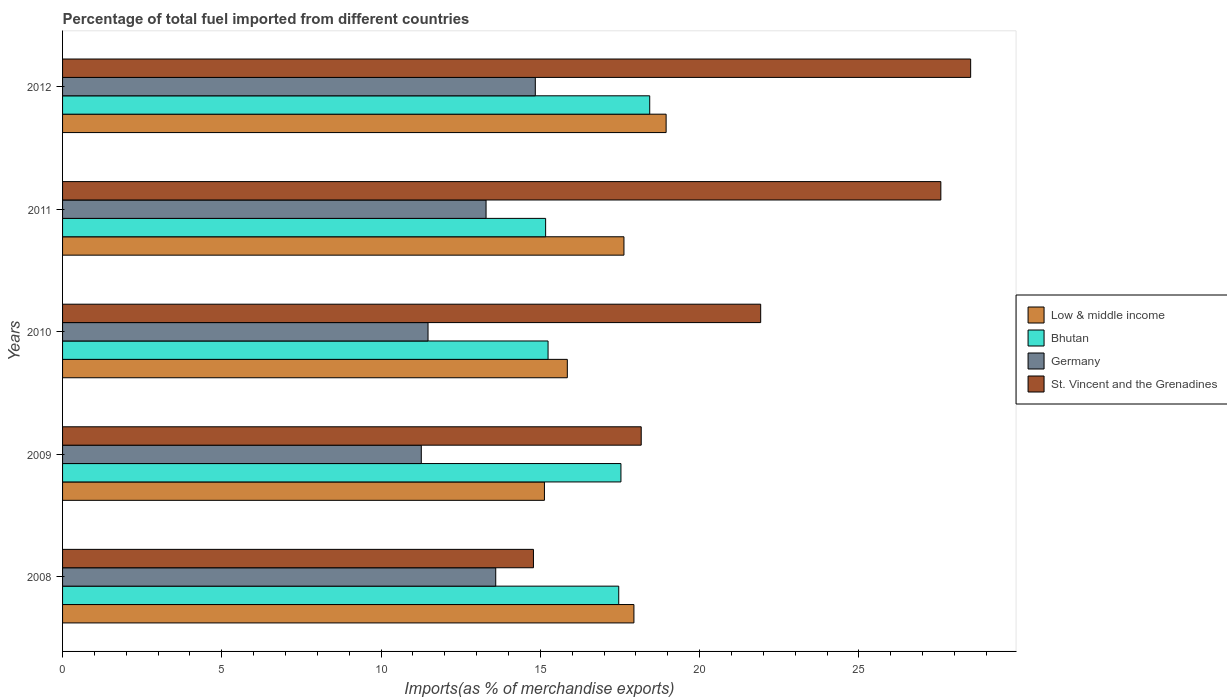How many different coloured bars are there?
Keep it short and to the point. 4. How many groups of bars are there?
Provide a short and direct response. 5. Are the number of bars per tick equal to the number of legend labels?
Your answer should be compact. Yes. What is the label of the 3rd group of bars from the top?
Ensure brevity in your answer.  2010. In how many cases, is the number of bars for a given year not equal to the number of legend labels?
Make the answer very short. 0. What is the percentage of imports to different countries in Bhutan in 2010?
Give a very brief answer. 15.24. Across all years, what is the maximum percentage of imports to different countries in Germany?
Provide a short and direct response. 14.84. Across all years, what is the minimum percentage of imports to different countries in St. Vincent and the Grenadines?
Ensure brevity in your answer.  14.78. In which year was the percentage of imports to different countries in Germany minimum?
Offer a very short reply. 2009. What is the total percentage of imports to different countries in St. Vincent and the Grenadines in the graph?
Offer a terse response. 110.95. What is the difference between the percentage of imports to different countries in Low & middle income in 2008 and that in 2012?
Your answer should be compact. -1.01. What is the difference between the percentage of imports to different countries in Bhutan in 2008 and the percentage of imports to different countries in Germany in 2012?
Keep it short and to the point. 2.62. What is the average percentage of imports to different countries in Germany per year?
Your answer should be compact. 12.89. In the year 2009, what is the difference between the percentage of imports to different countries in Germany and percentage of imports to different countries in St. Vincent and the Grenadines?
Keep it short and to the point. -6.9. In how many years, is the percentage of imports to different countries in St. Vincent and the Grenadines greater than 28 %?
Give a very brief answer. 1. What is the ratio of the percentage of imports to different countries in Low & middle income in 2009 to that in 2011?
Make the answer very short. 0.86. What is the difference between the highest and the second highest percentage of imports to different countries in Germany?
Offer a very short reply. 1.24. What is the difference between the highest and the lowest percentage of imports to different countries in Germany?
Give a very brief answer. 3.58. How many bars are there?
Your response must be concise. 20. Are all the bars in the graph horizontal?
Ensure brevity in your answer.  Yes. How many years are there in the graph?
Your answer should be very brief. 5. How are the legend labels stacked?
Ensure brevity in your answer.  Vertical. What is the title of the graph?
Keep it short and to the point. Percentage of total fuel imported from different countries. What is the label or title of the X-axis?
Provide a short and direct response. Imports(as % of merchandise exports). What is the Imports(as % of merchandise exports) of Low & middle income in 2008?
Keep it short and to the point. 17.94. What is the Imports(as % of merchandise exports) of Bhutan in 2008?
Your answer should be compact. 17.46. What is the Imports(as % of merchandise exports) in Germany in 2008?
Make the answer very short. 13.6. What is the Imports(as % of merchandise exports) of St. Vincent and the Grenadines in 2008?
Offer a very short reply. 14.78. What is the Imports(as % of merchandise exports) in Low & middle income in 2009?
Offer a very short reply. 15.13. What is the Imports(as % of merchandise exports) of Bhutan in 2009?
Your answer should be very brief. 17.53. What is the Imports(as % of merchandise exports) in Germany in 2009?
Make the answer very short. 11.26. What is the Imports(as % of merchandise exports) of St. Vincent and the Grenadines in 2009?
Give a very brief answer. 18.17. What is the Imports(as % of merchandise exports) of Low & middle income in 2010?
Make the answer very short. 15.85. What is the Imports(as % of merchandise exports) of Bhutan in 2010?
Make the answer very short. 15.24. What is the Imports(as % of merchandise exports) in Germany in 2010?
Your answer should be very brief. 11.47. What is the Imports(as % of merchandise exports) in St. Vincent and the Grenadines in 2010?
Provide a short and direct response. 21.92. What is the Imports(as % of merchandise exports) of Low & middle income in 2011?
Give a very brief answer. 17.62. What is the Imports(as % of merchandise exports) in Bhutan in 2011?
Provide a succinct answer. 15.16. What is the Imports(as % of merchandise exports) in Germany in 2011?
Make the answer very short. 13.3. What is the Imports(as % of merchandise exports) of St. Vincent and the Grenadines in 2011?
Make the answer very short. 27.57. What is the Imports(as % of merchandise exports) of Low & middle income in 2012?
Provide a short and direct response. 18.95. What is the Imports(as % of merchandise exports) of Bhutan in 2012?
Make the answer very short. 18.43. What is the Imports(as % of merchandise exports) of Germany in 2012?
Provide a succinct answer. 14.84. What is the Imports(as % of merchandise exports) of St. Vincent and the Grenadines in 2012?
Ensure brevity in your answer.  28.51. Across all years, what is the maximum Imports(as % of merchandise exports) in Low & middle income?
Make the answer very short. 18.95. Across all years, what is the maximum Imports(as % of merchandise exports) of Bhutan?
Your answer should be compact. 18.43. Across all years, what is the maximum Imports(as % of merchandise exports) of Germany?
Offer a terse response. 14.84. Across all years, what is the maximum Imports(as % of merchandise exports) of St. Vincent and the Grenadines?
Provide a succinct answer. 28.51. Across all years, what is the minimum Imports(as % of merchandise exports) of Low & middle income?
Make the answer very short. 15.13. Across all years, what is the minimum Imports(as % of merchandise exports) in Bhutan?
Give a very brief answer. 15.16. Across all years, what is the minimum Imports(as % of merchandise exports) of Germany?
Give a very brief answer. 11.26. Across all years, what is the minimum Imports(as % of merchandise exports) in St. Vincent and the Grenadines?
Provide a short and direct response. 14.78. What is the total Imports(as % of merchandise exports) of Low & middle income in the graph?
Your response must be concise. 85.48. What is the total Imports(as % of merchandise exports) in Bhutan in the graph?
Your answer should be compact. 83.83. What is the total Imports(as % of merchandise exports) of Germany in the graph?
Provide a succinct answer. 64.47. What is the total Imports(as % of merchandise exports) in St. Vincent and the Grenadines in the graph?
Your answer should be very brief. 110.95. What is the difference between the Imports(as % of merchandise exports) of Low & middle income in 2008 and that in 2009?
Keep it short and to the point. 2.81. What is the difference between the Imports(as % of merchandise exports) in Bhutan in 2008 and that in 2009?
Offer a very short reply. -0.07. What is the difference between the Imports(as % of merchandise exports) of Germany in 2008 and that in 2009?
Make the answer very short. 2.34. What is the difference between the Imports(as % of merchandise exports) of St. Vincent and the Grenadines in 2008 and that in 2009?
Keep it short and to the point. -3.38. What is the difference between the Imports(as % of merchandise exports) of Low & middle income in 2008 and that in 2010?
Your answer should be very brief. 2.09. What is the difference between the Imports(as % of merchandise exports) of Bhutan in 2008 and that in 2010?
Keep it short and to the point. 2.22. What is the difference between the Imports(as % of merchandise exports) in Germany in 2008 and that in 2010?
Your response must be concise. 2.13. What is the difference between the Imports(as % of merchandise exports) in St. Vincent and the Grenadines in 2008 and that in 2010?
Keep it short and to the point. -7.13. What is the difference between the Imports(as % of merchandise exports) of Low & middle income in 2008 and that in 2011?
Your answer should be compact. 0.31. What is the difference between the Imports(as % of merchandise exports) of Bhutan in 2008 and that in 2011?
Give a very brief answer. 2.3. What is the difference between the Imports(as % of merchandise exports) of Germany in 2008 and that in 2011?
Provide a succinct answer. 0.3. What is the difference between the Imports(as % of merchandise exports) of St. Vincent and the Grenadines in 2008 and that in 2011?
Ensure brevity in your answer.  -12.79. What is the difference between the Imports(as % of merchandise exports) of Low & middle income in 2008 and that in 2012?
Make the answer very short. -1.01. What is the difference between the Imports(as % of merchandise exports) in Bhutan in 2008 and that in 2012?
Your response must be concise. -0.97. What is the difference between the Imports(as % of merchandise exports) of Germany in 2008 and that in 2012?
Ensure brevity in your answer.  -1.24. What is the difference between the Imports(as % of merchandise exports) in St. Vincent and the Grenadines in 2008 and that in 2012?
Provide a short and direct response. -13.73. What is the difference between the Imports(as % of merchandise exports) of Low & middle income in 2009 and that in 2010?
Give a very brief answer. -0.72. What is the difference between the Imports(as % of merchandise exports) of Bhutan in 2009 and that in 2010?
Your answer should be very brief. 2.29. What is the difference between the Imports(as % of merchandise exports) in Germany in 2009 and that in 2010?
Provide a short and direct response. -0.21. What is the difference between the Imports(as % of merchandise exports) in St. Vincent and the Grenadines in 2009 and that in 2010?
Offer a terse response. -3.75. What is the difference between the Imports(as % of merchandise exports) of Low & middle income in 2009 and that in 2011?
Your answer should be compact. -2.5. What is the difference between the Imports(as % of merchandise exports) of Bhutan in 2009 and that in 2011?
Make the answer very short. 2.36. What is the difference between the Imports(as % of merchandise exports) in Germany in 2009 and that in 2011?
Keep it short and to the point. -2.03. What is the difference between the Imports(as % of merchandise exports) in St. Vincent and the Grenadines in 2009 and that in 2011?
Keep it short and to the point. -9.41. What is the difference between the Imports(as % of merchandise exports) of Low & middle income in 2009 and that in 2012?
Provide a succinct answer. -3.82. What is the difference between the Imports(as % of merchandise exports) of Bhutan in 2009 and that in 2012?
Ensure brevity in your answer.  -0.9. What is the difference between the Imports(as % of merchandise exports) of Germany in 2009 and that in 2012?
Ensure brevity in your answer.  -3.58. What is the difference between the Imports(as % of merchandise exports) of St. Vincent and the Grenadines in 2009 and that in 2012?
Keep it short and to the point. -10.34. What is the difference between the Imports(as % of merchandise exports) of Low & middle income in 2010 and that in 2011?
Offer a terse response. -1.78. What is the difference between the Imports(as % of merchandise exports) in Bhutan in 2010 and that in 2011?
Ensure brevity in your answer.  0.08. What is the difference between the Imports(as % of merchandise exports) of Germany in 2010 and that in 2011?
Your response must be concise. -1.82. What is the difference between the Imports(as % of merchandise exports) of St. Vincent and the Grenadines in 2010 and that in 2011?
Give a very brief answer. -5.66. What is the difference between the Imports(as % of merchandise exports) in Low & middle income in 2010 and that in 2012?
Your answer should be very brief. -3.1. What is the difference between the Imports(as % of merchandise exports) in Bhutan in 2010 and that in 2012?
Keep it short and to the point. -3.19. What is the difference between the Imports(as % of merchandise exports) of Germany in 2010 and that in 2012?
Ensure brevity in your answer.  -3.37. What is the difference between the Imports(as % of merchandise exports) of St. Vincent and the Grenadines in 2010 and that in 2012?
Keep it short and to the point. -6.59. What is the difference between the Imports(as % of merchandise exports) in Low & middle income in 2011 and that in 2012?
Offer a terse response. -1.32. What is the difference between the Imports(as % of merchandise exports) in Bhutan in 2011 and that in 2012?
Ensure brevity in your answer.  -3.27. What is the difference between the Imports(as % of merchandise exports) of Germany in 2011 and that in 2012?
Your answer should be compact. -1.55. What is the difference between the Imports(as % of merchandise exports) in St. Vincent and the Grenadines in 2011 and that in 2012?
Your answer should be very brief. -0.94. What is the difference between the Imports(as % of merchandise exports) in Low & middle income in 2008 and the Imports(as % of merchandise exports) in Bhutan in 2009?
Provide a succinct answer. 0.41. What is the difference between the Imports(as % of merchandise exports) in Low & middle income in 2008 and the Imports(as % of merchandise exports) in Germany in 2009?
Provide a short and direct response. 6.67. What is the difference between the Imports(as % of merchandise exports) of Low & middle income in 2008 and the Imports(as % of merchandise exports) of St. Vincent and the Grenadines in 2009?
Provide a short and direct response. -0.23. What is the difference between the Imports(as % of merchandise exports) of Bhutan in 2008 and the Imports(as % of merchandise exports) of Germany in 2009?
Keep it short and to the point. 6.2. What is the difference between the Imports(as % of merchandise exports) of Bhutan in 2008 and the Imports(as % of merchandise exports) of St. Vincent and the Grenadines in 2009?
Offer a terse response. -0.71. What is the difference between the Imports(as % of merchandise exports) in Germany in 2008 and the Imports(as % of merchandise exports) in St. Vincent and the Grenadines in 2009?
Offer a very short reply. -4.57. What is the difference between the Imports(as % of merchandise exports) of Low & middle income in 2008 and the Imports(as % of merchandise exports) of Bhutan in 2010?
Make the answer very short. 2.7. What is the difference between the Imports(as % of merchandise exports) in Low & middle income in 2008 and the Imports(as % of merchandise exports) in Germany in 2010?
Give a very brief answer. 6.46. What is the difference between the Imports(as % of merchandise exports) in Low & middle income in 2008 and the Imports(as % of merchandise exports) in St. Vincent and the Grenadines in 2010?
Your answer should be very brief. -3.98. What is the difference between the Imports(as % of merchandise exports) of Bhutan in 2008 and the Imports(as % of merchandise exports) of Germany in 2010?
Give a very brief answer. 5.99. What is the difference between the Imports(as % of merchandise exports) of Bhutan in 2008 and the Imports(as % of merchandise exports) of St. Vincent and the Grenadines in 2010?
Your answer should be compact. -4.46. What is the difference between the Imports(as % of merchandise exports) of Germany in 2008 and the Imports(as % of merchandise exports) of St. Vincent and the Grenadines in 2010?
Make the answer very short. -8.32. What is the difference between the Imports(as % of merchandise exports) in Low & middle income in 2008 and the Imports(as % of merchandise exports) in Bhutan in 2011?
Your answer should be very brief. 2.77. What is the difference between the Imports(as % of merchandise exports) of Low & middle income in 2008 and the Imports(as % of merchandise exports) of Germany in 2011?
Make the answer very short. 4.64. What is the difference between the Imports(as % of merchandise exports) in Low & middle income in 2008 and the Imports(as % of merchandise exports) in St. Vincent and the Grenadines in 2011?
Ensure brevity in your answer.  -9.64. What is the difference between the Imports(as % of merchandise exports) in Bhutan in 2008 and the Imports(as % of merchandise exports) in Germany in 2011?
Offer a very short reply. 4.17. What is the difference between the Imports(as % of merchandise exports) in Bhutan in 2008 and the Imports(as % of merchandise exports) in St. Vincent and the Grenadines in 2011?
Your response must be concise. -10.11. What is the difference between the Imports(as % of merchandise exports) in Germany in 2008 and the Imports(as % of merchandise exports) in St. Vincent and the Grenadines in 2011?
Your answer should be compact. -13.97. What is the difference between the Imports(as % of merchandise exports) of Low & middle income in 2008 and the Imports(as % of merchandise exports) of Bhutan in 2012?
Give a very brief answer. -0.5. What is the difference between the Imports(as % of merchandise exports) of Low & middle income in 2008 and the Imports(as % of merchandise exports) of Germany in 2012?
Your response must be concise. 3.1. What is the difference between the Imports(as % of merchandise exports) of Low & middle income in 2008 and the Imports(as % of merchandise exports) of St. Vincent and the Grenadines in 2012?
Provide a short and direct response. -10.57. What is the difference between the Imports(as % of merchandise exports) in Bhutan in 2008 and the Imports(as % of merchandise exports) in Germany in 2012?
Make the answer very short. 2.62. What is the difference between the Imports(as % of merchandise exports) of Bhutan in 2008 and the Imports(as % of merchandise exports) of St. Vincent and the Grenadines in 2012?
Your response must be concise. -11.05. What is the difference between the Imports(as % of merchandise exports) in Germany in 2008 and the Imports(as % of merchandise exports) in St. Vincent and the Grenadines in 2012?
Your answer should be compact. -14.91. What is the difference between the Imports(as % of merchandise exports) of Low & middle income in 2009 and the Imports(as % of merchandise exports) of Bhutan in 2010?
Ensure brevity in your answer.  -0.11. What is the difference between the Imports(as % of merchandise exports) of Low & middle income in 2009 and the Imports(as % of merchandise exports) of Germany in 2010?
Ensure brevity in your answer.  3.65. What is the difference between the Imports(as % of merchandise exports) in Low & middle income in 2009 and the Imports(as % of merchandise exports) in St. Vincent and the Grenadines in 2010?
Your response must be concise. -6.79. What is the difference between the Imports(as % of merchandise exports) of Bhutan in 2009 and the Imports(as % of merchandise exports) of Germany in 2010?
Offer a terse response. 6.06. What is the difference between the Imports(as % of merchandise exports) of Bhutan in 2009 and the Imports(as % of merchandise exports) of St. Vincent and the Grenadines in 2010?
Offer a terse response. -4.39. What is the difference between the Imports(as % of merchandise exports) of Germany in 2009 and the Imports(as % of merchandise exports) of St. Vincent and the Grenadines in 2010?
Offer a very short reply. -10.65. What is the difference between the Imports(as % of merchandise exports) in Low & middle income in 2009 and the Imports(as % of merchandise exports) in Bhutan in 2011?
Make the answer very short. -0.04. What is the difference between the Imports(as % of merchandise exports) of Low & middle income in 2009 and the Imports(as % of merchandise exports) of Germany in 2011?
Keep it short and to the point. 1.83. What is the difference between the Imports(as % of merchandise exports) of Low & middle income in 2009 and the Imports(as % of merchandise exports) of St. Vincent and the Grenadines in 2011?
Keep it short and to the point. -12.44. What is the difference between the Imports(as % of merchandise exports) of Bhutan in 2009 and the Imports(as % of merchandise exports) of Germany in 2011?
Provide a short and direct response. 4.23. What is the difference between the Imports(as % of merchandise exports) of Bhutan in 2009 and the Imports(as % of merchandise exports) of St. Vincent and the Grenadines in 2011?
Give a very brief answer. -10.04. What is the difference between the Imports(as % of merchandise exports) of Germany in 2009 and the Imports(as % of merchandise exports) of St. Vincent and the Grenadines in 2011?
Offer a terse response. -16.31. What is the difference between the Imports(as % of merchandise exports) in Low & middle income in 2009 and the Imports(as % of merchandise exports) in Bhutan in 2012?
Your answer should be compact. -3.31. What is the difference between the Imports(as % of merchandise exports) in Low & middle income in 2009 and the Imports(as % of merchandise exports) in Germany in 2012?
Your answer should be very brief. 0.29. What is the difference between the Imports(as % of merchandise exports) in Low & middle income in 2009 and the Imports(as % of merchandise exports) in St. Vincent and the Grenadines in 2012?
Provide a short and direct response. -13.38. What is the difference between the Imports(as % of merchandise exports) in Bhutan in 2009 and the Imports(as % of merchandise exports) in Germany in 2012?
Your answer should be very brief. 2.69. What is the difference between the Imports(as % of merchandise exports) of Bhutan in 2009 and the Imports(as % of merchandise exports) of St. Vincent and the Grenadines in 2012?
Keep it short and to the point. -10.98. What is the difference between the Imports(as % of merchandise exports) in Germany in 2009 and the Imports(as % of merchandise exports) in St. Vincent and the Grenadines in 2012?
Keep it short and to the point. -17.25. What is the difference between the Imports(as % of merchandise exports) of Low & middle income in 2010 and the Imports(as % of merchandise exports) of Bhutan in 2011?
Offer a very short reply. 0.68. What is the difference between the Imports(as % of merchandise exports) in Low & middle income in 2010 and the Imports(as % of merchandise exports) in Germany in 2011?
Your response must be concise. 2.55. What is the difference between the Imports(as % of merchandise exports) of Low & middle income in 2010 and the Imports(as % of merchandise exports) of St. Vincent and the Grenadines in 2011?
Your answer should be very brief. -11.73. What is the difference between the Imports(as % of merchandise exports) in Bhutan in 2010 and the Imports(as % of merchandise exports) in Germany in 2011?
Ensure brevity in your answer.  1.95. What is the difference between the Imports(as % of merchandise exports) in Bhutan in 2010 and the Imports(as % of merchandise exports) in St. Vincent and the Grenadines in 2011?
Ensure brevity in your answer.  -12.33. What is the difference between the Imports(as % of merchandise exports) of Germany in 2010 and the Imports(as % of merchandise exports) of St. Vincent and the Grenadines in 2011?
Your answer should be very brief. -16.1. What is the difference between the Imports(as % of merchandise exports) of Low & middle income in 2010 and the Imports(as % of merchandise exports) of Bhutan in 2012?
Provide a succinct answer. -2.59. What is the difference between the Imports(as % of merchandise exports) of Low & middle income in 2010 and the Imports(as % of merchandise exports) of Germany in 2012?
Your response must be concise. 1. What is the difference between the Imports(as % of merchandise exports) of Low & middle income in 2010 and the Imports(as % of merchandise exports) of St. Vincent and the Grenadines in 2012?
Provide a short and direct response. -12.66. What is the difference between the Imports(as % of merchandise exports) in Bhutan in 2010 and the Imports(as % of merchandise exports) in Germany in 2012?
Make the answer very short. 0.4. What is the difference between the Imports(as % of merchandise exports) in Bhutan in 2010 and the Imports(as % of merchandise exports) in St. Vincent and the Grenadines in 2012?
Offer a terse response. -13.27. What is the difference between the Imports(as % of merchandise exports) in Germany in 2010 and the Imports(as % of merchandise exports) in St. Vincent and the Grenadines in 2012?
Ensure brevity in your answer.  -17.04. What is the difference between the Imports(as % of merchandise exports) in Low & middle income in 2011 and the Imports(as % of merchandise exports) in Bhutan in 2012?
Your answer should be compact. -0.81. What is the difference between the Imports(as % of merchandise exports) of Low & middle income in 2011 and the Imports(as % of merchandise exports) of Germany in 2012?
Keep it short and to the point. 2.78. What is the difference between the Imports(as % of merchandise exports) of Low & middle income in 2011 and the Imports(as % of merchandise exports) of St. Vincent and the Grenadines in 2012?
Keep it short and to the point. -10.88. What is the difference between the Imports(as % of merchandise exports) of Bhutan in 2011 and the Imports(as % of merchandise exports) of Germany in 2012?
Your response must be concise. 0.32. What is the difference between the Imports(as % of merchandise exports) of Bhutan in 2011 and the Imports(as % of merchandise exports) of St. Vincent and the Grenadines in 2012?
Make the answer very short. -13.34. What is the difference between the Imports(as % of merchandise exports) of Germany in 2011 and the Imports(as % of merchandise exports) of St. Vincent and the Grenadines in 2012?
Provide a short and direct response. -15.21. What is the average Imports(as % of merchandise exports) in Low & middle income per year?
Your answer should be very brief. 17.1. What is the average Imports(as % of merchandise exports) in Bhutan per year?
Make the answer very short. 16.77. What is the average Imports(as % of merchandise exports) of Germany per year?
Your answer should be compact. 12.89. What is the average Imports(as % of merchandise exports) of St. Vincent and the Grenadines per year?
Keep it short and to the point. 22.19. In the year 2008, what is the difference between the Imports(as % of merchandise exports) in Low & middle income and Imports(as % of merchandise exports) in Bhutan?
Give a very brief answer. 0.48. In the year 2008, what is the difference between the Imports(as % of merchandise exports) of Low & middle income and Imports(as % of merchandise exports) of Germany?
Ensure brevity in your answer.  4.34. In the year 2008, what is the difference between the Imports(as % of merchandise exports) of Low & middle income and Imports(as % of merchandise exports) of St. Vincent and the Grenadines?
Offer a terse response. 3.15. In the year 2008, what is the difference between the Imports(as % of merchandise exports) of Bhutan and Imports(as % of merchandise exports) of Germany?
Ensure brevity in your answer.  3.86. In the year 2008, what is the difference between the Imports(as % of merchandise exports) of Bhutan and Imports(as % of merchandise exports) of St. Vincent and the Grenadines?
Give a very brief answer. 2.68. In the year 2008, what is the difference between the Imports(as % of merchandise exports) in Germany and Imports(as % of merchandise exports) in St. Vincent and the Grenadines?
Offer a very short reply. -1.18. In the year 2009, what is the difference between the Imports(as % of merchandise exports) in Low & middle income and Imports(as % of merchandise exports) in Bhutan?
Keep it short and to the point. -2.4. In the year 2009, what is the difference between the Imports(as % of merchandise exports) of Low & middle income and Imports(as % of merchandise exports) of Germany?
Provide a short and direct response. 3.87. In the year 2009, what is the difference between the Imports(as % of merchandise exports) in Low & middle income and Imports(as % of merchandise exports) in St. Vincent and the Grenadines?
Give a very brief answer. -3.04. In the year 2009, what is the difference between the Imports(as % of merchandise exports) in Bhutan and Imports(as % of merchandise exports) in Germany?
Your response must be concise. 6.27. In the year 2009, what is the difference between the Imports(as % of merchandise exports) in Bhutan and Imports(as % of merchandise exports) in St. Vincent and the Grenadines?
Your answer should be very brief. -0.64. In the year 2009, what is the difference between the Imports(as % of merchandise exports) in Germany and Imports(as % of merchandise exports) in St. Vincent and the Grenadines?
Provide a short and direct response. -6.9. In the year 2010, what is the difference between the Imports(as % of merchandise exports) of Low & middle income and Imports(as % of merchandise exports) of Bhutan?
Provide a succinct answer. 0.6. In the year 2010, what is the difference between the Imports(as % of merchandise exports) in Low & middle income and Imports(as % of merchandise exports) in Germany?
Provide a succinct answer. 4.37. In the year 2010, what is the difference between the Imports(as % of merchandise exports) of Low & middle income and Imports(as % of merchandise exports) of St. Vincent and the Grenadines?
Make the answer very short. -6.07. In the year 2010, what is the difference between the Imports(as % of merchandise exports) of Bhutan and Imports(as % of merchandise exports) of Germany?
Your answer should be compact. 3.77. In the year 2010, what is the difference between the Imports(as % of merchandise exports) in Bhutan and Imports(as % of merchandise exports) in St. Vincent and the Grenadines?
Your answer should be compact. -6.68. In the year 2010, what is the difference between the Imports(as % of merchandise exports) of Germany and Imports(as % of merchandise exports) of St. Vincent and the Grenadines?
Make the answer very short. -10.44. In the year 2011, what is the difference between the Imports(as % of merchandise exports) of Low & middle income and Imports(as % of merchandise exports) of Bhutan?
Make the answer very short. 2.46. In the year 2011, what is the difference between the Imports(as % of merchandise exports) in Low & middle income and Imports(as % of merchandise exports) in Germany?
Offer a terse response. 4.33. In the year 2011, what is the difference between the Imports(as % of merchandise exports) in Low & middle income and Imports(as % of merchandise exports) in St. Vincent and the Grenadines?
Offer a very short reply. -9.95. In the year 2011, what is the difference between the Imports(as % of merchandise exports) of Bhutan and Imports(as % of merchandise exports) of Germany?
Offer a terse response. 1.87. In the year 2011, what is the difference between the Imports(as % of merchandise exports) in Bhutan and Imports(as % of merchandise exports) in St. Vincent and the Grenadines?
Ensure brevity in your answer.  -12.41. In the year 2011, what is the difference between the Imports(as % of merchandise exports) of Germany and Imports(as % of merchandise exports) of St. Vincent and the Grenadines?
Make the answer very short. -14.28. In the year 2012, what is the difference between the Imports(as % of merchandise exports) in Low & middle income and Imports(as % of merchandise exports) in Bhutan?
Give a very brief answer. 0.51. In the year 2012, what is the difference between the Imports(as % of merchandise exports) in Low & middle income and Imports(as % of merchandise exports) in Germany?
Provide a short and direct response. 4.11. In the year 2012, what is the difference between the Imports(as % of merchandise exports) in Low & middle income and Imports(as % of merchandise exports) in St. Vincent and the Grenadines?
Your answer should be very brief. -9.56. In the year 2012, what is the difference between the Imports(as % of merchandise exports) in Bhutan and Imports(as % of merchandise exports) in Germany?
Ensure brevity in your answer.  3.59. In the year 2012, what is the difference between the Imports(as % of merchandise exports) of Bhutan and Imports(as % of merchandise exports) of St. Vincent and the Grenadines?
Provide a succinct answer. -10.08. In the year 2012, what is the difference between the Imports(as % of merchandise exports) in Germany and Imports(as % of merchandise exports) in St. Vincent and the Grenadines?
Your answer should be very brief. -13.67. What is the ratio of the Imports(as % of merchandise exports) of Low & middle income in 2008 to that in 2009?
Make the answer very short. 1.19. What is the ratio of the Imports(as % of merchandise exports) in Germany in 2008 to that in 2009?
Keep it short and to the point. 1.21. What is the ratio of the Imports(as % of merchandise exports) of St. Vincent and the Grenadines in 2008 to that in 2009?
Make the answer very short. 0.81. What is the ratio of the Imports(as % of merchandise exports) in Low & middle income in 2008 to that in 2010?
Your answer should be very brief. 1.13. What is the ratio of the Imports(as % of merchandise exports) of Bhutan in 2008 to that in 2010?
Ensure brevity in your answer.  1.15. What is the ratio of the Imports(as % of merchandise exports) in Germany in 2008 to that in 2010?
Provide a short and direct response. 1.19. What is the ratio of the Imports(as % of merchandise exports) of St. Vincent and the Grenadines in 2008 to that in 2010?
Provide a short and direct response. 0.67. What is the ratio of the Imports(as % of merchandise exports) in Low & middle income in 2008 to that in 2011?
Your response must be concise. 1.02. What is the ratio of the Imports(as % of merchandise exports) in Bhutan in 2008 to that in 2011?
Offer a very short reply. 1.15. What is the ratio of the Imports(as % of merchandise exports) of Germany in 2008 to that in 2011?
Give a very brief answer. 1.02. What is the ratio of the Imports(as % of merchandise exports) of St. Vincent and the Grenadines in 2008 to that in 2011?
Offer a terse response. 0.54. What is the ratio of the Imports(as % of merchandise exports) in Low & middle income in 2008 to that in 2012?
Your response must be concise. 0.95. What is the ratio of the Imports(as % of merchandise exports) of Bhutan in 2008 to that in 2012?
Offer a terse response. 0.95. What is the ratio of the Imports(as % of merchandise exports) of Germany in 2008 to that in 2012?
Ensure brevity in your answer.  0.92. What is the ratio of the Imports(as % of merchandise exports) in St. Vincent and the Grenadines in 2008 to that in 2012?
Keep it short and to the point. 0.52. What is the ratio of the Imports(as % of merchandise exports) of Low & middle income in 2009 to that in 2010?
Your response must be concise. 0.95. What is the ratio of the Imports(as % of merchandise exports) in Bhutan in 2009 to that in 2010?
Your response must be concise. 1.15. What is the ratio of the Imports(as % of merchandise exports) of Germany in 2009 to that in 2010?
Your response must be concise. 0.98. What is the ratio of the Imports(as % of merchandise exports) in St. Vincent and the Grenadines in 2009 to that in 2010?
Make the answer very short. 0.83. What is the ratio of the Imports(as % of merchandise exports) in Low & middle income in 2009 to that in 2011?
Your answer should be very brief. 0.86. What is the ratio of the Imports(as % of merchandise exports) in Bhutan in 2009 to that in 2011?
Give a very brief answer. 1.16. What is the ratio of the Imports(as % of merchandise exports) in Germany in 2009 to that in 2011?
Your response must be concise. 0.85. What is the ratio of the Imports(as % of merchandise exports) in St. Vincent and the Grenadines in 2009 to that in 2011?
Offer a terse response. 0.66. What is the ratio of the Imports(as % of merchandise exports) of Low & middle income in 2009 to that in 2012?
Offer a terse response. 0.8. What is the ratio of the Imports(as % of merchandise exports) of Bhutan in 2009 to that in 2012?
Ensure brevity in your answer.  0.95. What is the ratio of the Imports(as % of merchandise exports) of Germany in 2009 to that in 2012?
Ensure brevity in your answer.  0.76. What is the ratio of the Imports(as % of merchandise exports) in St. Vincent and the Grenadines in 2009 to that in 2012?
Provide a short and direct response. 0.64. What is the ratio of the Imports(as % of merchandise exports) of Low & middle income in 2010 to that in 2011?
Give a very brief answer. 0.9. What is the ratio of the Imports(as % of merchandise exports) in Germany in 2010 to that in 2011?
Provide a short and direct response. 0.86. What is the ratio of the Imports(as % of merchandise exports) of St. Vincent and the Grenadines in 2010 to that in 2011?
Make the answer very short. 0.79. What is the ratio of the Imports(as % of merchandise exports) of Low & middle income in 2010 to that in 2012?
Ensure brevity in your answer.  0.84. What is the ratio of the Imports(as % of merchandise exports) in Bhutan in 2010 to that in 2012?
Provide a succinct answer. 0.83. What is the ratio of the Imports(as % of merchandise exports) of Germany in 2010 to that in 2012?
Ensure brevity in your answer.  0.77. What is the ratio of the Imports(as % of merchandise exports) in St. Vincent and the Grenadines in 2010 to that in 2012?
Keep it short and to the point. 0.77. What is the ratio of the Imports(as % of merchandise exports) in Low & middle income in 2011 to that in 2012?
Offer a terse response. 0.93. What is the ratio of the Imports(as % of merchandise exports) in Bhutan in 2011 to that in 2012?
Provide a short and direct response. 0.82. What is the ratio of the Imports(as % of merchandise exports) in Germany in 2011 to that in 2012?
Offer a terse response. 0.9. What is the ratio of the Imports(as % of merchandise exports) of St. Vincent and the Grenadines in 2011 to that in 2012?
Your response must be concise. 0.97. What is the difference between the highest and the second highest Imports(as % of merchandise exports) in Low & middle income?
Give a very brief answer. 1.01. What is the difference between the highest and the second highest Imports(as % of merchandise exports) in Bhutan?
Make the answer very short. 0.9. What is the difference between the highest and the second highest Imports(as % of merchandise exports) of Germany?
Give a very brief answer. 1.24. What is the difference between the highest and the second highest Imports(as % of merchandise exports) in St. Vincent and the Grenadines?
Your answer should be very brief. 0.94. What is the difference between the highest and the lowest Imports(as % of merchandise exports) in Low & middle income?
Your response must be concise. 3.82. What is the difference between the highest and the lowest Imports(as % of merchandise exports) in Bhutan?
Your answer should be compact. 3.27. What is the difference between the highest and the lowest Imports(as % of merchandise exports) in Germany?
Your answer should be compact. 3.58. What is the difference between the highest and the lowest Imports(as % of merchandise exports) in St. Vincent and the Grenadines?
Offer a terse response. 13.73. 